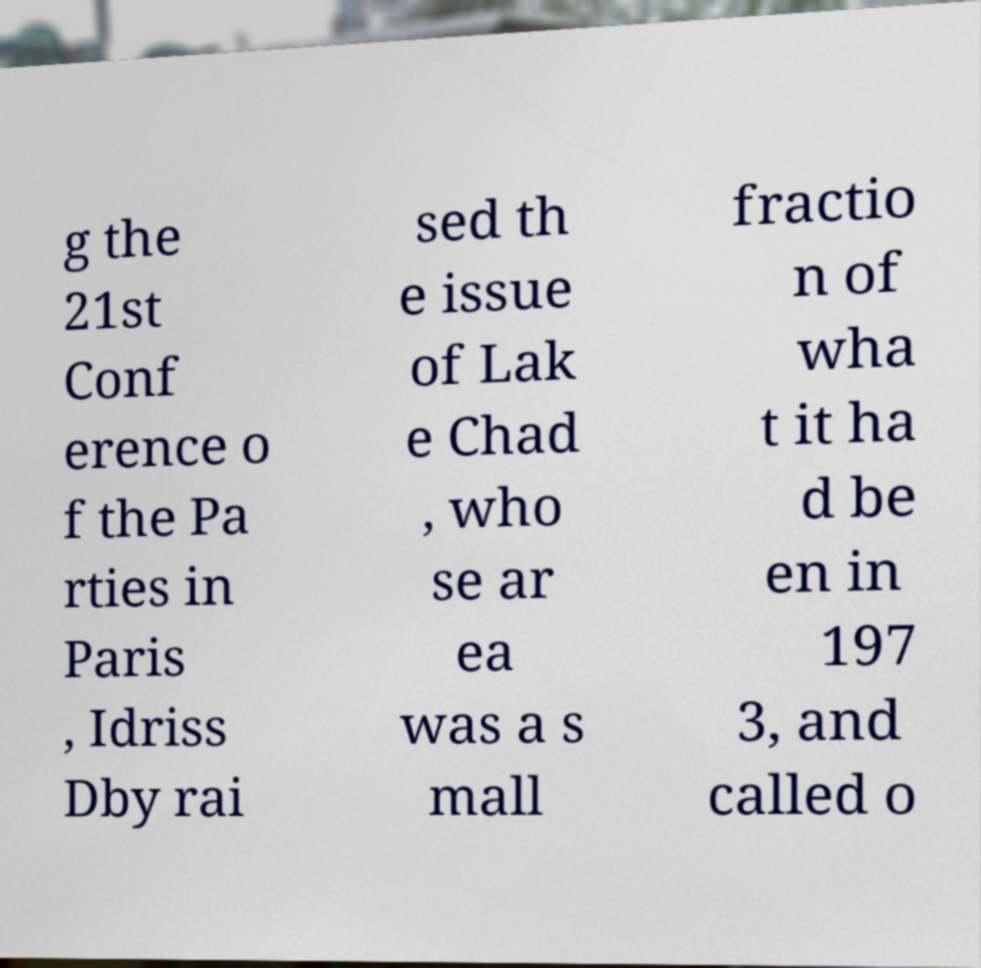Please read and relay the text visible in this image. What does it say? g the 21st Conf erence o f the Pa rties in Paris , Idriss Dby rai sed th e issue of Lak e Chad , who se ar ea was a s mall fractio n of wha t it ha d be en in 197 3, and called o 